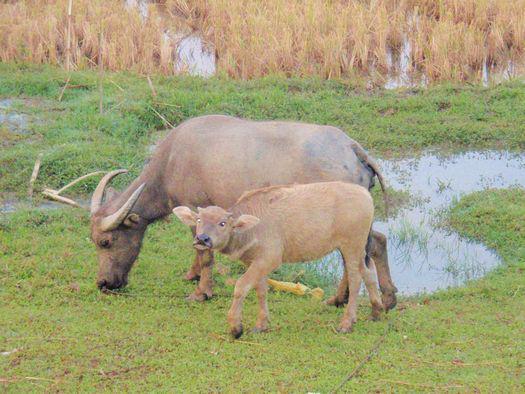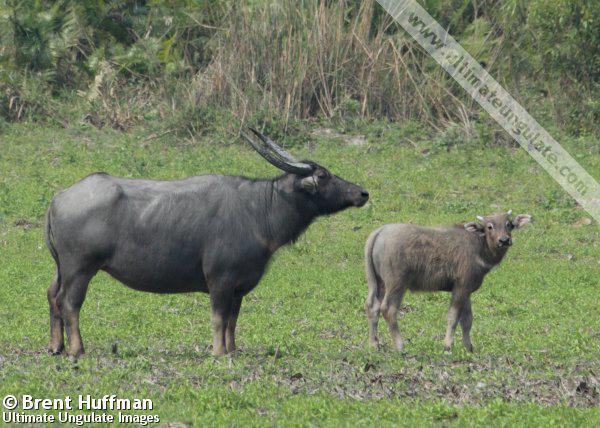The first image is the image on the left, the second image is the image on the right. Assess this claim about the two images: "There is water visible in at least one of the images.". Correct or not? Answer yes or no. Yes. The first image is the image on the left, the second image is the image on the right. For the images shown, is this caption "There is exactly one animal in the image on the right." true? Answer yes or no. No. 